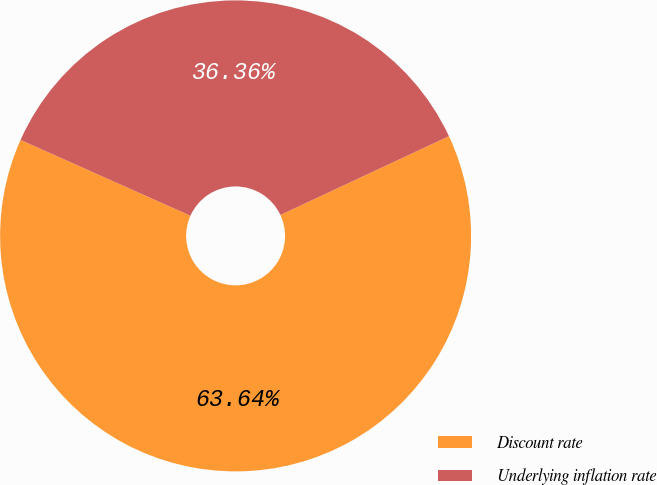Convert chart to OTSL. <chart><loc_0><loc_0><loc_500><loc_500><pie_chart><fcel>Discount rate<fcel>Underlying inflation rate<nl><fcel>63.64%<fcel>36.36%<nl></chart> 